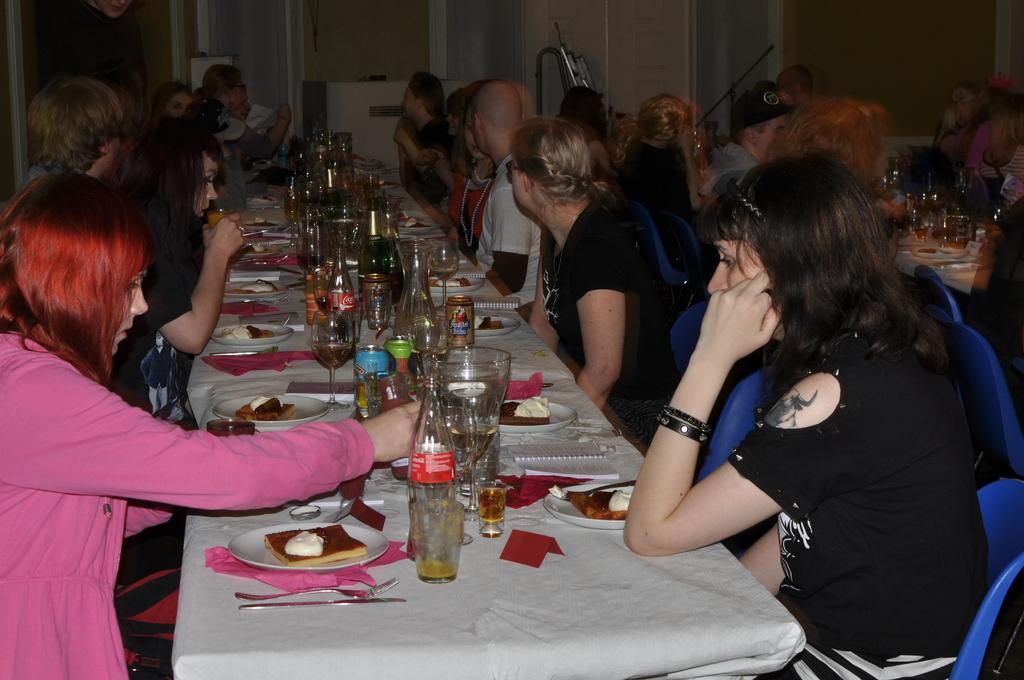How would you summarize this image in a sentence or two? In this image I can see number of people are sitting on blue colour chairs. I can also see tables and on these tables I can see white tablecloths, number of plates, number of bottles, number of glasses, few cans and I can see food in every plate. I can also see few spoons, few forks and knives. 